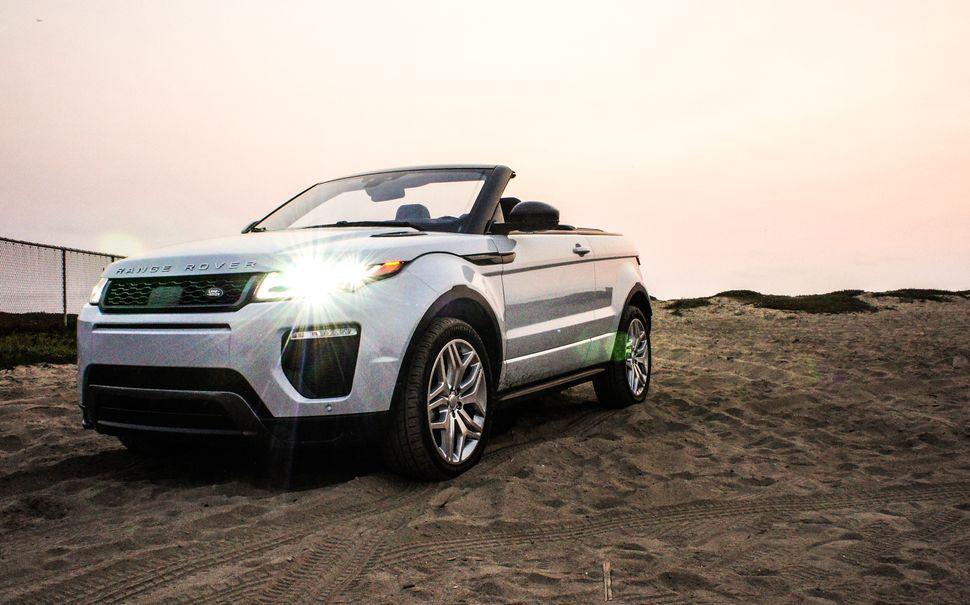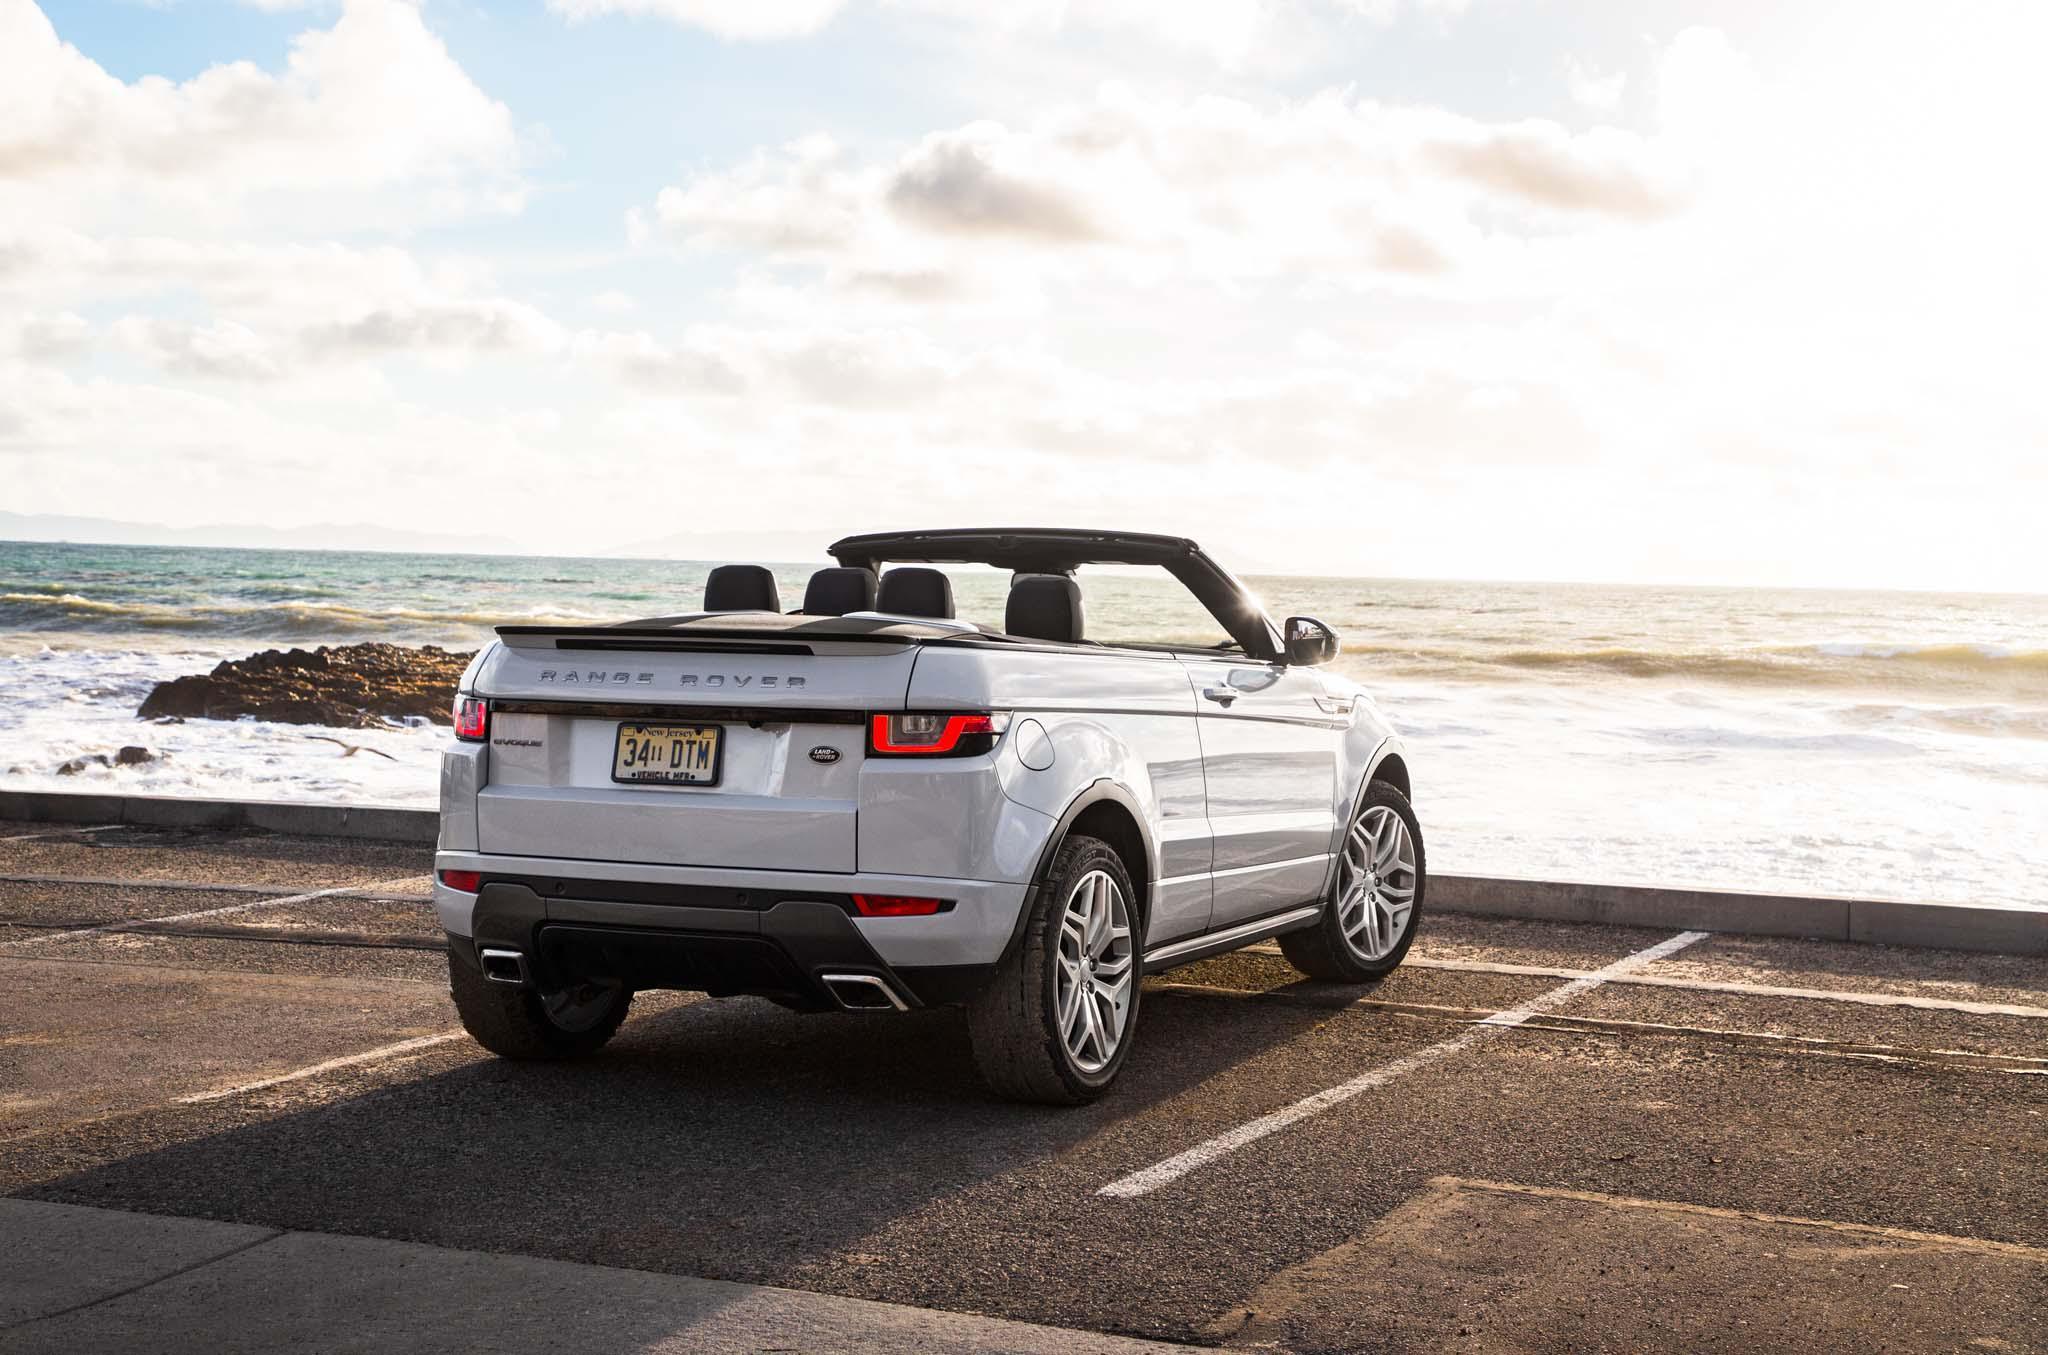The first image is the image on the left, the second image is the image on the right. Assess this claim about the two images: "a convertible is in a parking space overlooking the beach". Correct or not? Answer yes or no. Yes. The first image is the image on the left, the second image is the image on the right. Examine the images to the left and right. Is the description "One of the images shows an orange vehicle." accurate? Answer yes or no. No. 